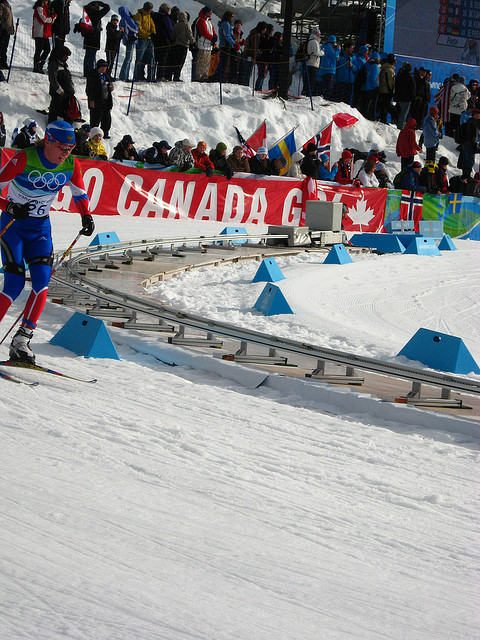Please identify all text content in this image. CANADA GO G 66 